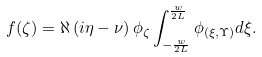<formula> <loc_0><loc_0><loc_500><loc_500>f ( \zeta ) = \aleph \left ( i \eta - \nu \right ) \phi _ { \zeta } \int _ { - \frac { w } { 2 L } } ^ { \frac { w } { 2 L } } \phi _ { ( \xi , \Upsilon ) } d \xi .</formula> 